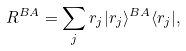Convert formula to latex. <formula><loc_0><loc_0><loc_500><loc_500>R ^ { B A } = \sum _ { j } r _ { j } | r _ { j } \rangle ^ { B A } \langle r _ { j } | ,</formula> 